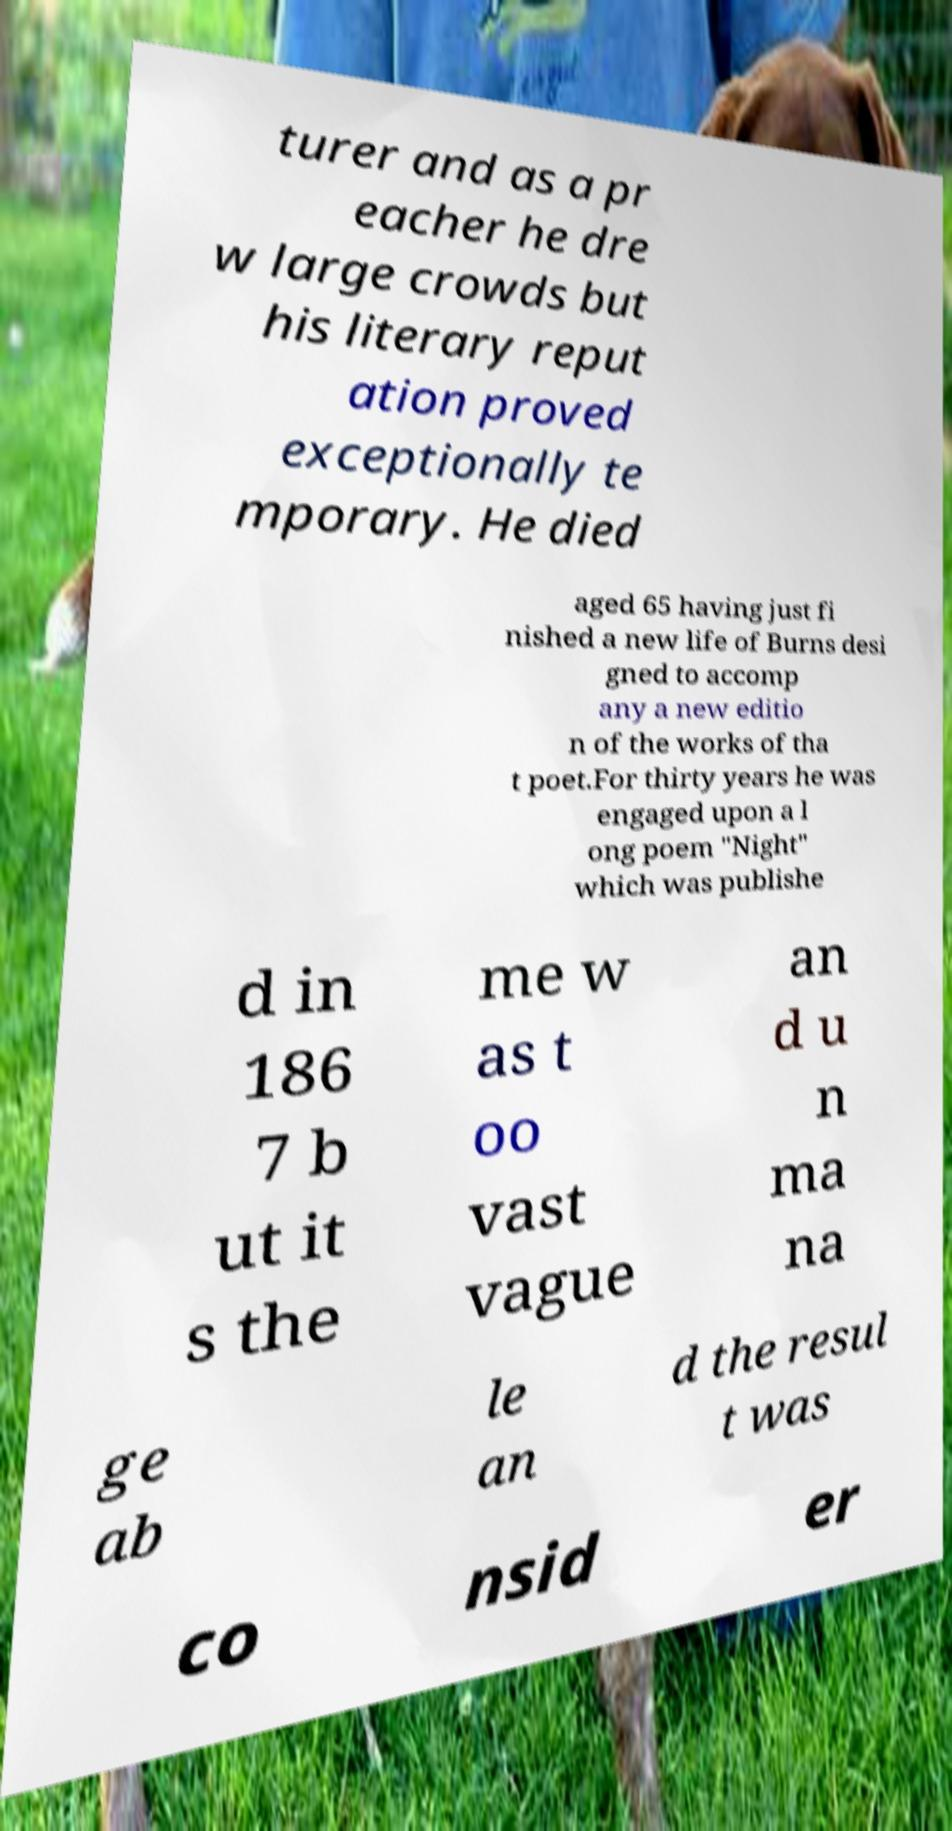Please identify and transcribe the text found in this image. turer and as a pr eacher he dre w large crowds but his literary reput ation proved exceptionally te mporary. He died aged 65 having just fi nished a new life of Burns desi gned to accomp any a new editio n of the works of tha t poet.For thirty years he was engaged upon a l ong poem "Night" which was publishe d in 186 7 b ut it s the me w as t oo vast vague an d u n ma na ge ab le an d the resul t was co nsid er 